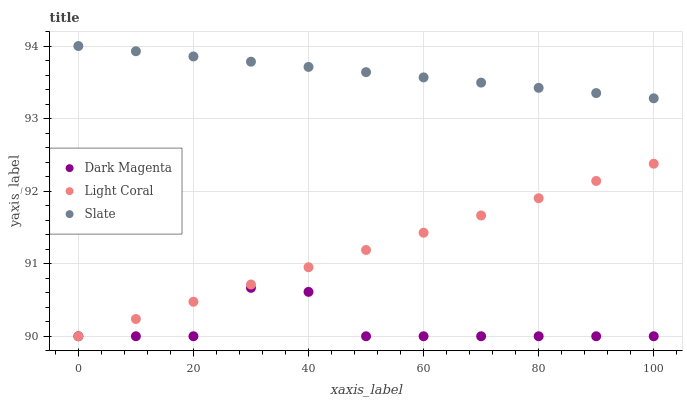Does Dark Magenta have the minimum area under the curve?
Answer yes or no. Yes. Does Slate have the maximum area under the curve?
Answer yes or no. Yes. Does Slate have the minimum area under the curve?
Answer yes or no. No. Does Dark Magenta have the maximum area under the curve?
Answer yes or no. No. Is Slate the smoothest?
Answer yes or no. Yes. Is Dark Magenta the roughest?
Answer yes or no. Yes. Is Dark Magenta the smoothest?
Answer yes or no. No. Is Slate the roughest?
Answer yes or no. No. Does Light Coral have the lowest value?
Answer yes or no. Yes. Does Slate have the lowest value?
Answer yes or no. No. Does Slate have the highest value?
Answer yes or no. Yes. Does Dark Magenta have the highest value?
Answer yes or no. No. Is Dark Magenta less than Slate?
Answer yes or no. Yes. Is Slate greater than Dark Magenta?
Answer yes or no. Yes. Does Light Coral intersect Dark Magenta?
Answer yes or no. Yes. Is Light Coral less than Dark Magenta?
Answer yes or no. No. Is Light Coral greater than Dark Magenta?
Answer yes or no. No. Does Dark Magenta intersect Slate?
Answer yes or no. No. 